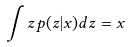Convert formula to latex. <formula><loc_0><loc_0><loc_500><loc_500>\int z p ( z | x ) d z = x</formula> 